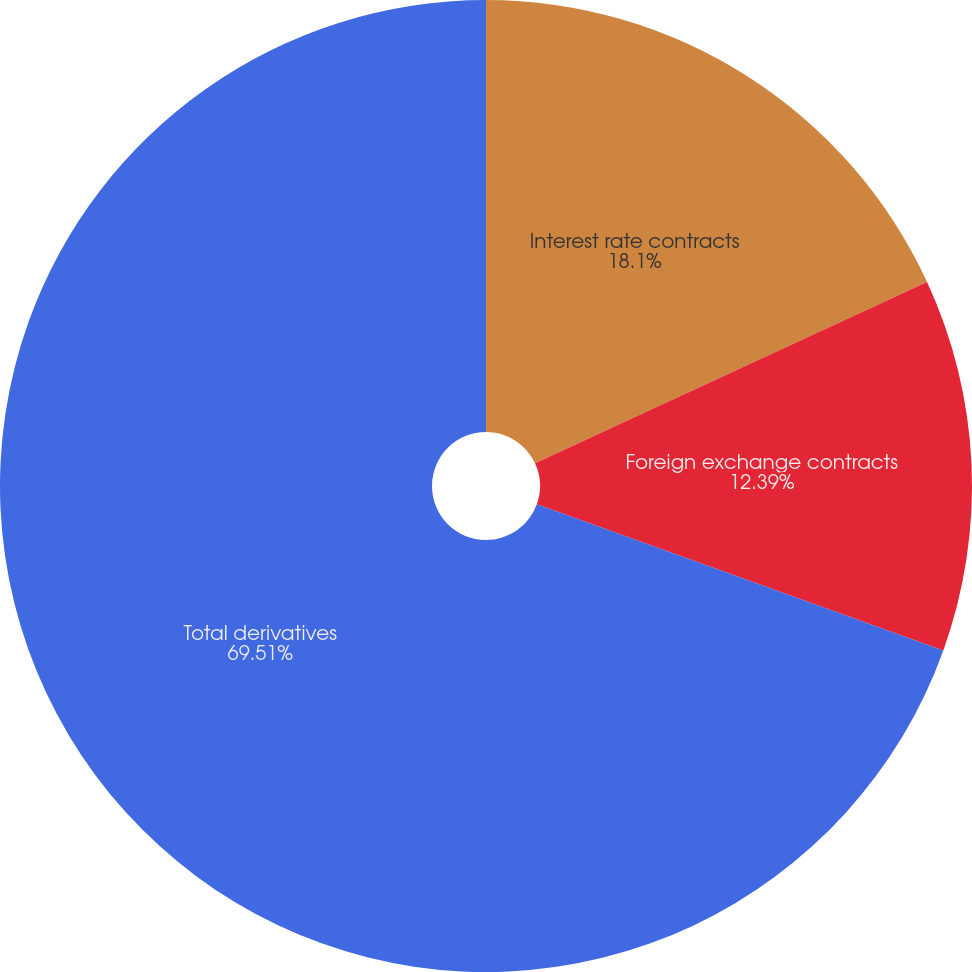<chart> <loc_0><loc_0><loc_500><loc_500><pie_chart><fcel>Interest rate contracts<fcel>Foreign exchange contracts<fcel>Total derivatives<nl><fcel>18.1%<fcel>12.39%<fcel>69.5%<nl></chart> 